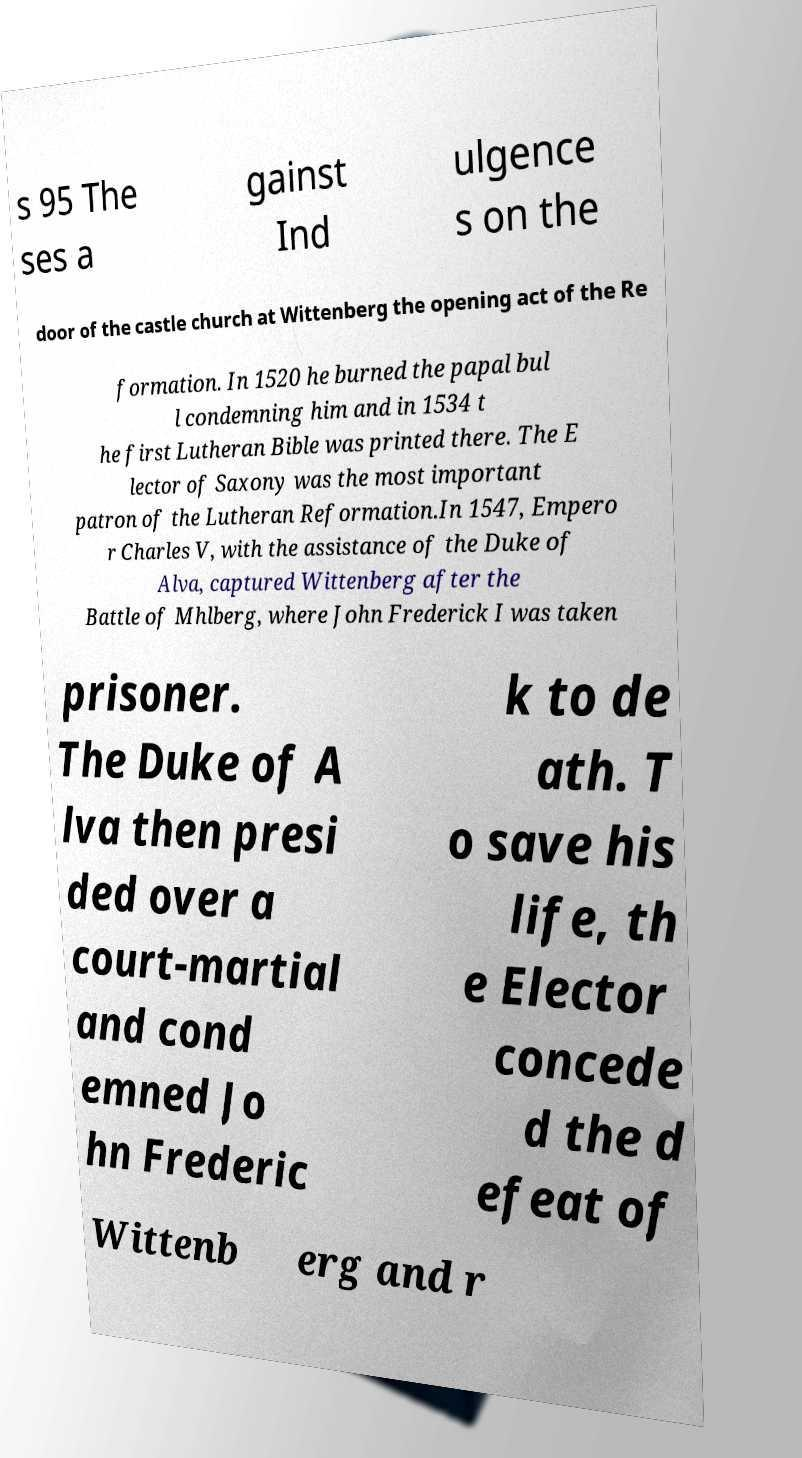There's text embedded in this image that I need extracted. Can you transcribe it verbatim? s 95 The ses a gainst Ind ulgence s on the door of the castle church at Wittenberg the opening act of the Re formation. In 1520 he burned the papal bul l condemning him and in 1534 t he first Lutheran Bible was printed there. The E lector of Saxony was the most important patron of the Lutheran Reformation.In 1547, Empero r Charles V, with the assistance of the Duke of Alva, captured Wittenberg after the Battle of Mhlberg, where John Frederick I was taken prisoner. The Duke of A lva then presi ded over a court-martial and cond emned Jo hn Frederic k to de ath. T o save his life, th e Elector concede d the d efeat of Wittenb erg and r 